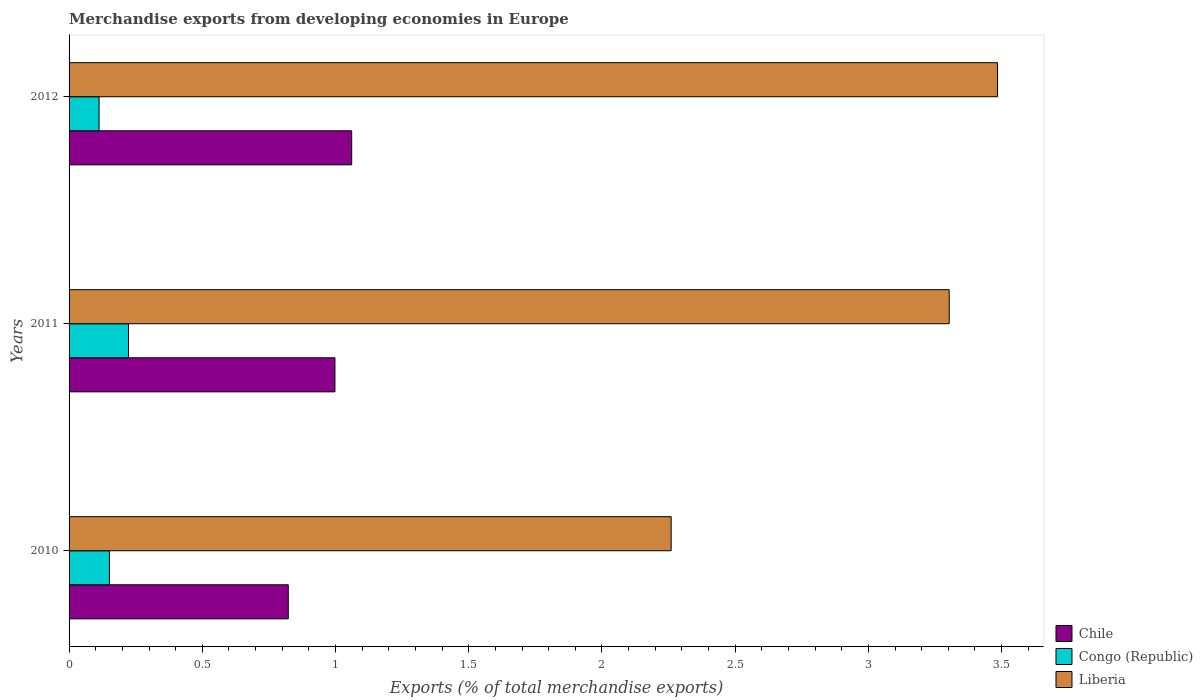How many groups of bars are there?
Provide a short and direct response. 3. How many bars are there on the 2nd tick from the top?
Ensure brevity in your answer.  3. How many bars are there on the 2nd tick from the bottom?
Keep it short and to the point. 3. In how many cases, is the number of bars for a given year not equal to the number of legend labels?
Ensure brevity in your answer.  0. What is the percentage of total merchandise exports in Chile in 2010?
Keep it short and to the point. 0.82. Across all years, what is the maximum percentage of total merchandise exports in Liberia?
Provide a short and direct response. 3.48. Across all years, what is the minimum percentage of total merchandise exports in Congo (Republic)?
Your answer should be compact. 0.11. What is the total percentage of total merchandise exports in Congo (Republic) in the graph?
Your response must be concise. 0.49. What is the difference between the percentage of total merchandise exports in Congo (Republic) in 2011 and that in 2012?
Give a very brief answer. 0.11. What is the difference between the percentage of total merchandise exports in Congo (Republic) in 2010 and the percentage of total merchandise exports in Liberia in 2011?
Your answer should be compact. -3.15. What is the average percentage of total merchandise exports in Chile per year?
Provide a short and direct response. 0.96. In the year 2012, what is the difference between the percentage of total merchandise exports in Chile and percentage of total merchandise exports in Liberia?
Provide a short and direct response. -2.42. What is the ratio of the percentage of total merchandise exports in Chile in 2010 to that in 2012?
Make the answer very short. 0.78. Is the percentage of total merchandise exports in Liberia in 2010 less than that in 2012?
Give a very brief answer. Yes. Is the difference between the percentage of total merchandise exports in Chile in 2011 and 2012 greater than the difference between the percentage of total merchandise exports in Liberia in 2011 and 2012?
Offer a very short reply. Yes. What is the difference between the highest and the second highest percentage of total merchandise exports in Liberia?
Provide a succinct answer. 0.18. What is the difference between the highest and the lowest percentage of total merchandise exports in Liberia?
Give a very brief answer. 1.22. Is the sum of the percentage of total merchandise exports in Congo (Republic) in 2010 and 2012 greater than the maximum percentage of total merchandise exports in Liberia across all years?
Give a very brief answer. No. What does the 2nd bar from the top in 2012 represents?
Provide a short and direct response. Congo (Republic). What does the 3rd bar from the bottom in 2011 represents?
Offer a terse response. Liberia. Is it the case that in every year, the sum of the percentage of total merchandise exports in Liberia and percentage of total merchandise exports in Congo (Republic) is greater than the percentage of total merchandise exports in Chile?
Ensure brevity in your answer.  Yes. What is the difference between two consecutive major ticks on the X-axis?
Offer a terse response. 0.5. Are the values on the major ticks of X-axis written in scientific E-notation?
Provide a succinct answer. No. Does the graph contain grids?
Your answer should be compact. No. How many legend labels are there?
Your answer should be very brief. 3. What is the title of the graph?
Make the answer very short. Merchandise exports from developing economies in Europe. What is the label or title of the X-axis?
Make the answer very short. Exports (% of total merchandise exports). What is the Exports (% of total merchandise exports) in Chile in 2010?
Make the answer very short. 0.82. What is the Exports (% of total merchandise exports) in Congo (Republic) in 2010?
Ensure brevity in your answer.  0.15. What is the Exports (% of total merchandise exports) in Liberia in 2010?
Your answer should be very brief. 2.26. What is the Exports (% of total merchandise exports) in Chile in 2011?
Ensure brevity in your answer.  1. What is the Exports (% of total merchandise exports) in Congo (Republic) in 2011?
Provide a short and direct response. 0.22. What is the Exports (% of total merchandise exports) of Liberia in 2011?
Offer a terse response. 3.3. What is the Exports (% of total merchandise exports) of Chile in 2012?
Your response must be concise. 1.06. What is the Exports (% of total merchandise exports) in Congo (Republic) in 2012?
Make the answer very short. 0.11. What is the Exports (% of total merchandise exports) of Liberia in 2012?
Offer a very short reply. 3.48. Across all years, what is the maximum Exports (% of total merchandise exports) in Chile?
Your response must be concise. 1.06. Across all years, what is the maximum Exports (% of total merchandise exports) of Congo (Republic)?
Offer a very short reply. 0.22. Across all years, what is the maximum Exports (% of total merchandise exports) of Liberia?
Provide a succinct answer. 3.48. Across all years, what is the minimum Exports (% of total merchandise exports) in Chile?
Provide a succinct answer. 0.82. Across all years, what is the minimum Exports (% of total merchandise exports) of Congo (Republic)?
Provide a short and direct response. 0.11. Across all years, what is the minimum Exports (% of total merchandise exports) in Liberia?
Provide a succinct answer. 2.26. What is the total Exports (% of total merchandise exports) in Chile in the graph?
Keep it short and to the point. 2.88. What is the total Exports (% of total merchandise exports) of Congo (Republic) in the graph?
Make the answer very short. 0.49. What is the total Exports (% of total merchandise exports) in Liberia in the graph?
Your answer should be compact. 9.05. What is the difference between the Exports (% of total merchandise exports) in Chile in 2010 and that in 2011?
Offer a very short reply. -0.18. What is the difference between the Exports (% of total merchandise exports) of Congo (Republic) in 2010 and that in 2011?
Ensure brevity in your answer.  -0.07. What is the difference between the Exports (% of total merchandise exports) of Liberia in 2010 and that in 2011?
Offer a very short reply. -1.04. What is the difference between the Exports (% of total merchandise exports) of Chile in 2010 and that in 2012?
Provide a short and direct response. -0.24. What is the difference between the Exports (% of total merchandise exports) in Congo (Republic) in 2010 and that in 2012?
Provide a short and direct response. 0.04. What is the difference between the Exports (% of total merchandise exports) of Liberia in 2010 and that in 2012?
Your response must be concise. -1.23. What is the difference between the Exports (% of total merchandise exports) in Chile in 2011 and that in 2012?
Offer a very short reply. -0.06. What is the difference between the Exports (% of total merchandise exports) in Congo (Republic) in 2011 and that in 2012?
Make the answer very short. 0.11. What is the difference between the Exports (% of total merchandise exports) in Liberia in 2011 and that in 2012?
Keep it short and to the point. -0.18. What is the difference between the Exports (% of total merchandise exports) in Chile in 2010 and the Exports (% of total merchandise exports) in Congo (Republic) in 2011?
Offer a very short reply. 0.6. What is the difference between the Exports (% of total merchandise exports) in Chile in 2010 and the Exports (% of total merchandise exports) in Liberia in 2011?
Make the answer very short. -2.48. What is the difference between the Exports (% of total merchandise exports) of Congo (Republic) in 2010 and the Exports (% of total merchandise exports) of Liberia in 2011?
Give a very brief answer. -3.15. What is the difference between the Exports (% of total merchandise exports) in Chile in 2010 and the Exports (% of total merchandise exports) in Congo (Republic) in 2012?
Offer a very short reply. 0.71. What is the difference between the Exports (% of total merchandise exports) of Chile in 2010 and the Exports (% of total merchandise exports) of Liberia in 2012?
Your answer should be compact. -2.66. What is the difference between the Exports (% of total merchandise exports) in Congo (Republic) in 2010 and the Exports (% of total merchandise exports) in Liberia in 2012?
Keep it short and to the point. -3.33. What is the difference between the Exports (% of total merchandise exports) in Chile in 2011 and the Exports (% of total merchandise exports) in Congo (Republic) in 2012?
Make the answer very short. 0.89. What is the difference between the Exports (% of total merchandise exports) in Chile in 2011 and the Exports (% of total merchandise exports) in Liberia in 2012?
Give a very brief answer. -2.49. What is the difference between the Exports (% of total merchandise exports) in Congo (Republic) in 2011 and the Exports (% of total merchandise exports) in Liberia in 2012?
Your response must be concise. -3.26. What is the average Exports (% of total merchandise exports) in Chile per year?
Provide a short and direct response. 0.96. What is the average Exports (% of total merchandise exports) of Congo (Republic) per year?
Make the answer very short. 0.16. What is the average Exports (% of total merchandise exports) in Liberia per year?
Keep it short and to the point. 3.02. In the year 2010, what is the difference between the Exports (% of total merchandise exports) in Chile and Exports (% of total merchandise exports) in Congo (Republic)?
Ensure brevity in your answer.  0.67. In the year 2010, what is the difference between the Exports (% of total merchandise exports) of Chile and Exports (% of total merchandise exports) of Liberia?
Ensure brevity in your answer.  -1.44. In the year 2010, what is the difference between the Exports (% of total merchandise exports) of Congo (Republic) and Exports (% of total merchandise exports) of Liberia?
Keep it short and to the point. -2.11. In the year 2011, what is the difference between the Exports (% of total merchandise exports) in Chile and Exports (% of total merchandise exports) in Congo (Republic)?
Your answer should be very brief. 0.77. In the year 2011, what is the difference between the Exports (% of total merchandise exports) in Chile and Exports (% of total merchandise exports) in Liberia?
Ensure brevity in your answer.  -2.31. In the year 2011, what is the difference between the Exports (% of total merchandise exports) of Congo (Republic) and Exports (% of total merchandise exports) of Liberia?
Give a very brief answer. -3.08. In the year 2012, what is the difference between the Exports (% of total merchandise exports) in Chile and Exports (% of total merchandise exports) in Congo (Republic)?
Provide a succinct answer. 0.95. In the year 2012, what is the difference between the Exports (% of total merchandise exports) of Chile and Exports (% of total merchandise exports) of Liberia?
Provide a succinct answer. -2.42. In the year 2012, what is the difference between the Exports (% of total merchandise exports) in Congo (Republic) and Exports (% of total merchandise exports) in Liberia?
Your answer should be compact. -3.37. What is the ratio of the Exports (% of total merchandise exports) in Chile in 2010 to that in 2011?
Provide a short and direct response. 0.82. What is the ratio of the Exports (% of total merchandise exports) in Congo (Republic) in 2010 to that in 2011?
Provide a succinct answer. 0.68. What is the ratio of the Exports (% of total merchandise exports) of Liberia in 2010 to that in 2011?
Offer a terse response. 0.68. What is the ratio of the Exports (% of total merchandise exports) of Chile in 2010 to that in 2012?
Ensure brevity in your answer.  0.78. What is the ratio of the Exports (% of total merchandise exports) of Congo (Republic) in 2010 to that in 2012?
Provide a short and direct response. 1.35. What is the ratio of the Exports (% of total merchandise exports) of Liberia in 2010 to that in 2012?
Provide a short and direct response. 0.65. What is the ratio of the Exports (% of total merchandise exports) of Chile in 2011 to that in 2012?
Your response must be concise. 0.94. What is the ratio of the Exports (% of total merchandise exports) of Congo (Republic) in 2011 to that in 2012?
Give a very brief answer. 1.98. What is the ratio of the Exports (% of total merchandise exports) in Liberia in 2011 to that in 2012?
Provide a short and direct response. 0.95. What is the difference between the highest and the second highest Exports (% of total merchandise exports) in Chile?
Offer a very short reply. 0.06. What is the difference between the highest and the second highest Exports (% of total merchandise exports) of Congo (Republic)?
Offer a very short reply. 0.07. What is the difference between the highest and the second highest Exports (% of total merchandise exports) of Liberia?
Provide a short and direct response. 0.18. What is the difference between the highest and the lowest Exports (% of total merchandise exports) of Chile?
Make the answer very short. 0.24. What is the difference between the highest and the lowest Exports (% of total merchandise exports) in Congo (Republic)?
Provide a short and direct response. 0.11. What is the difference between the highest and the lowest Exports (% of total merchandise exports) in Liberia?
Provide a succinct answer. 1.23. 